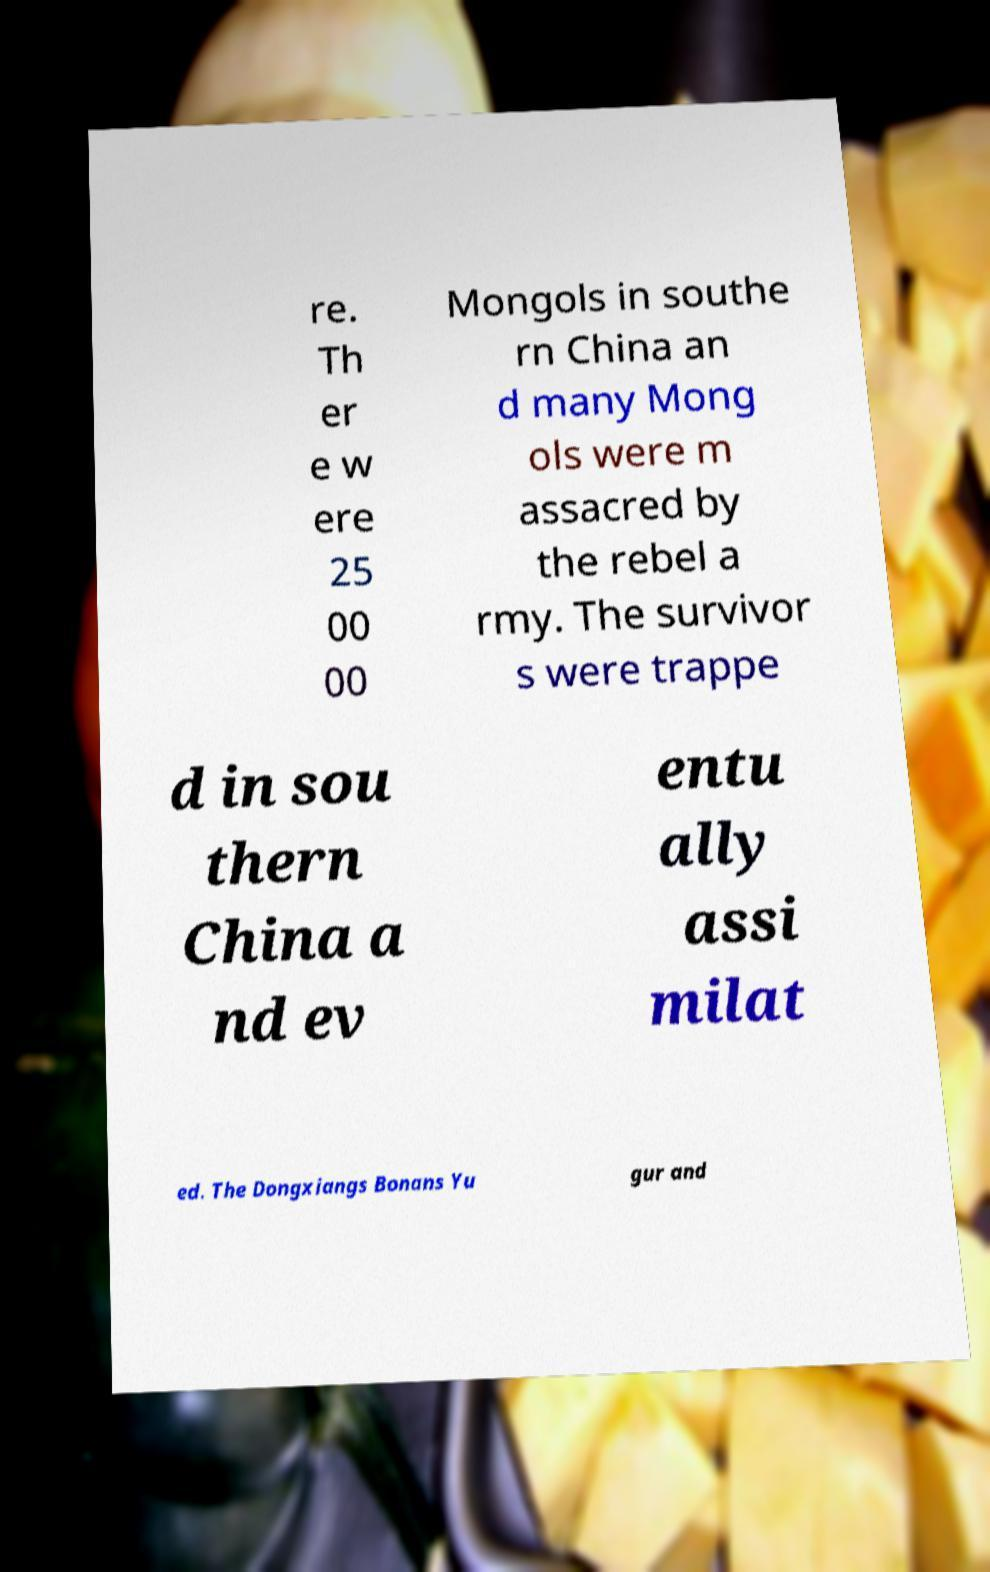What messages or text are displayed in this image? I need them in a readable, typed format. re. Th er e w ere 25 00 00 Mongols in southe rn China an d many Mong ols were m assacred by the rebel a rmy. The survivor s were trappe d in sou thern China a nd ev entu ally assi milat ed. The Dongxiangs Bonans Yu gur and 